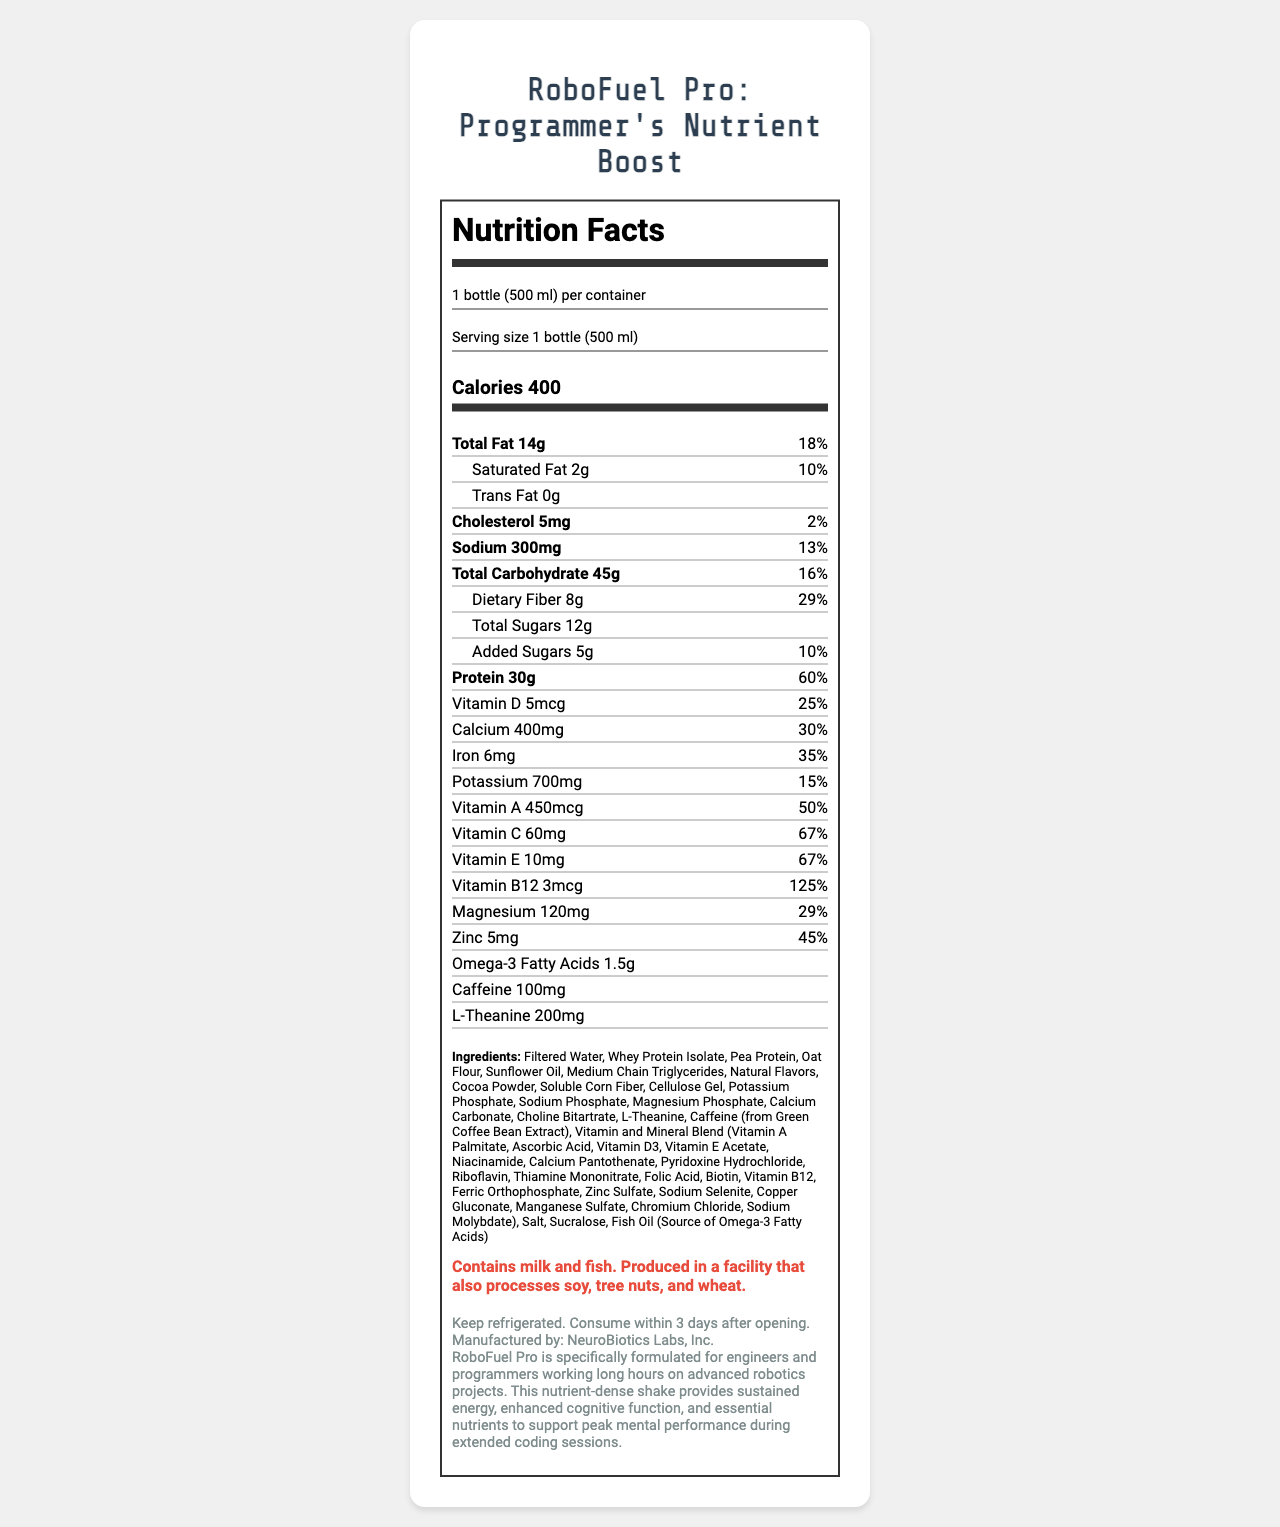what is the serving size per container? The serving size per container is explicitly stated as "1 bottle (500 ml)".
Answer: 1 bottle (500 ml) how many grams of total fat are in the shake? The total fat content is directly listed as "14g".
Answer: 14g what percentage of the daily value of protein does one serving provide? The document shows that the protein content per serving covers 60% of the daily value.
Answer: 60% how much vitamin C is in one serving? The amount of vitamin C per serving is listed as "60mg".
Answer: 60mg what is the sodium content in one serving? The sodium content is directly listed as "300mg".
Answer: 300mg which ingredient is a source of Omega-3 Fatty Acids? The ingredient list mentions "Fish Oil (Source of Omega-3 Fatty Acids)".
Answer: Fish Oil does the product contain any trans fat? It is clearly stated that the product contains "0g" of trans fat.
Answer: No what is the total carbohydrate content per serving? A. 35g B. 45g C. 55g D. 65g The total carbohydrate content per serving is listed as "45g".
Answer: B. 45g which vitamin has the highest daily value percentage? A. Vitamin A B. Vitamin B12 C. Vitamin C D. Vitamin D Vitamin B12 has a daily value percentage of 125%, which is the highest among the listed vitamins.
Answer: B. Vitamin B12 is the product safe for someone with a fish allergy? The allergen information states "Contains milk and fish".
Answer: No summarize the nutrition profile and purpose of RoboFuel Pro. The product is tailored for providing energy and cognitive benefits for individuals engaged in intensive tasks. The detailed nutrition information outlines the shake's content, fulfilling various dietary requirements.
Answer: RoboFuel Pro is a nutrient-dense meal replacement shake specifically designed for engineers and programmers working long hours on advanced robotics projects. It provides sustained energy, enhanced cognitive function, and essential nutrients. Each 500 ml bottle provides 400 calories, 14g of total fat, 45g of total carbohydrates, 30g of protein, and various vitamins and minerals. Key ingredients include Whey Protein Isolate, Pea Protein, Oat Flour, and Sunflower Oil. what is the manufacturing company of RoboFuel Pro? The document lists NeuroBiotics Labs, Inc. as the manufacturing company in the product info section.
Answer: NeuroBiotics Labs, Inc. how long can you consume the shake after opening? The storage instructions state to "Consume within 3 days after opening."
Answer: 3 days does the product contain any artificial sweeteners? The ingredient list includes "Sucralose", which is an artificial sweetener.
Answer: Yes which of the following vitamins is not listed in the nutrition facts? A. Vitamin K B. Vitamin A C. Vitamin D D. Vitamin E Vitamin K is not listed among the vitamins in the document.
Answer: A. Vitamin K what is the total sugar content in the shake? The total sugars content is listed as "12g".
Answer: 12g who is the target audience for RoboFuel Pro? The product description specifies that the shake is formulated for engineers and programmers working on advanced robotics.
Answer: Engineers and programmers working long hours on advanced robotics projects what is the main cognitive enhancer mentioned in the ingredients? L-Theanine is mentioned in the ingredients list as a cognitive enhancer.
Answer: L-Theanine what is the approximate caffeine content in one serving? The document lists the caffeine content as "100mg".
Answer: 100mg what kind of facility is RoboFuel Pro produced in, considering allergens? According to the allergen information, the product is produced in a facility that also processes soy, tree nuts, and wheat.
Answer: A facility that processes soy, tree nuts, and wheat how much dietary fiber does the shake contain? The dietary fiber content per serving is listed as "8g".
Answer: 8g what is the phosphorus compound listed in the ingredients? The list of ingredients includes "Potassium Phosphate".
Answer: Potassium Phosphate what are the instructions for storage before opening? The document does not provide any information about storage instructions before opening.
Answer: Cannot be determined how many grams of saturated fat are there per serving? The document lists the saturated fat content as "2g".
Answer: 2g 